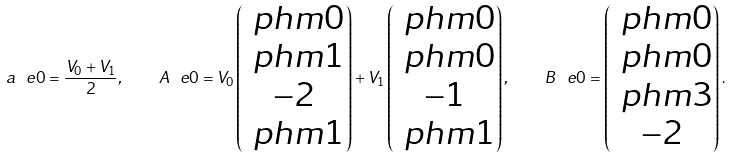Convert formula to latex. <formula><loc_0><loc_0><loc_500><loc_500>a ^ { \ } e 0 = \frac { V _ { 0 } + V _ { 1 } } { 2 } , \quad A ^ { \ } e 0 = V _ { 0 } \begin{pmatrix} \ p h m 0 \\ \ p h m 1 \\ - 2 \\ \ p h m 1 \end{pmatrix} + V _ { 1 } \begin{pmatrix} \ p h m 0 \\ \ p h m 0 \\ - 1 \\ \ p h m 1 \end{pmatrix} , \quad B ^ { \ } e 0 = \begin{pmatrix} \ p h m 0 \\ \ p h m 0 \\ \ p h m 3 \\ - 2 \end{pmatrix} .</formula> 